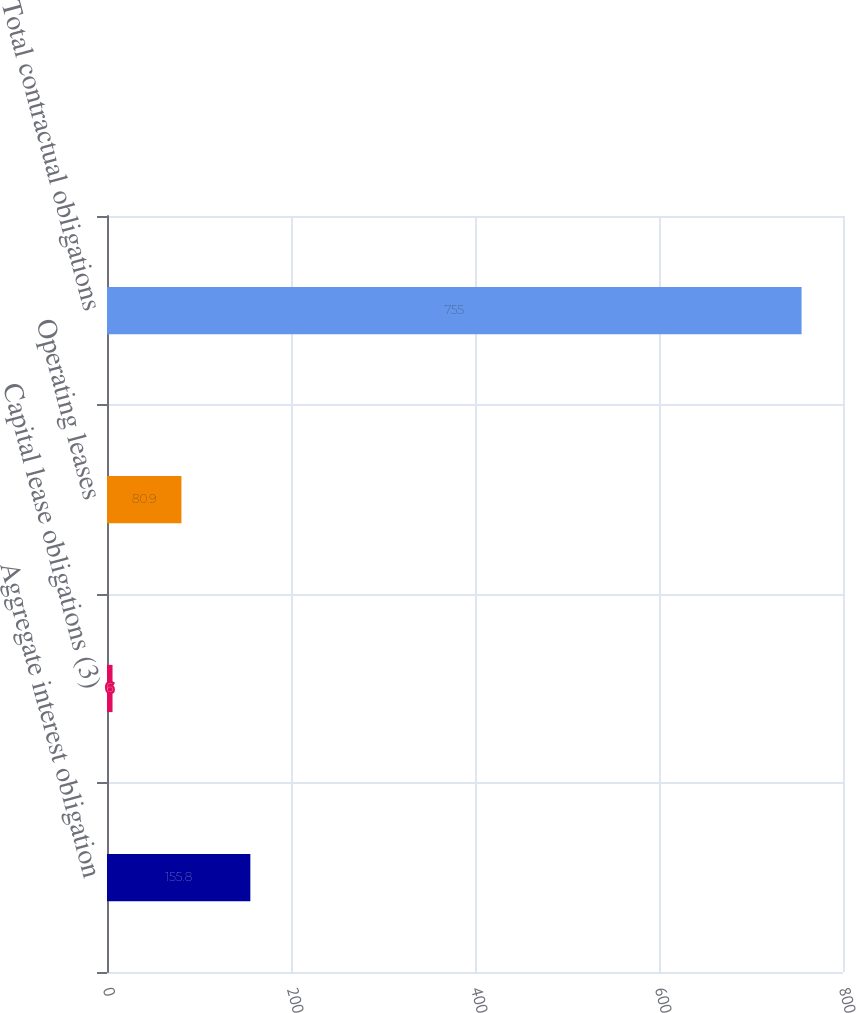<chart> <loc_0><loc_0><loc_500><loc_500><bar_chart><fcel>Aggregate interest obligation<fcel>Capital lease obligations (3)<fcel>Operating leases<fcel>Total contractual obligations<nl><fcel>155.8<fcel>6<fcel>80.9<fcel>755<nl></chart> 